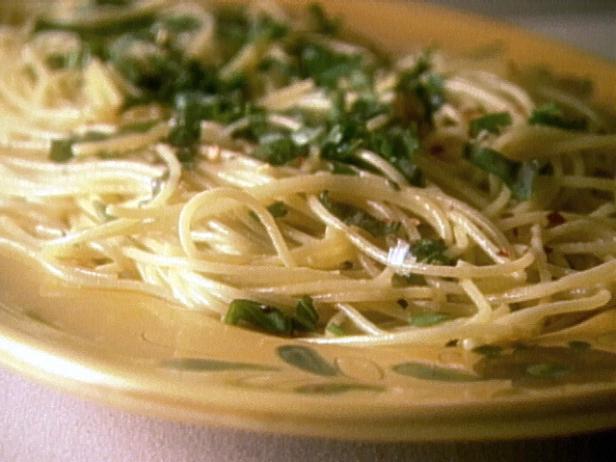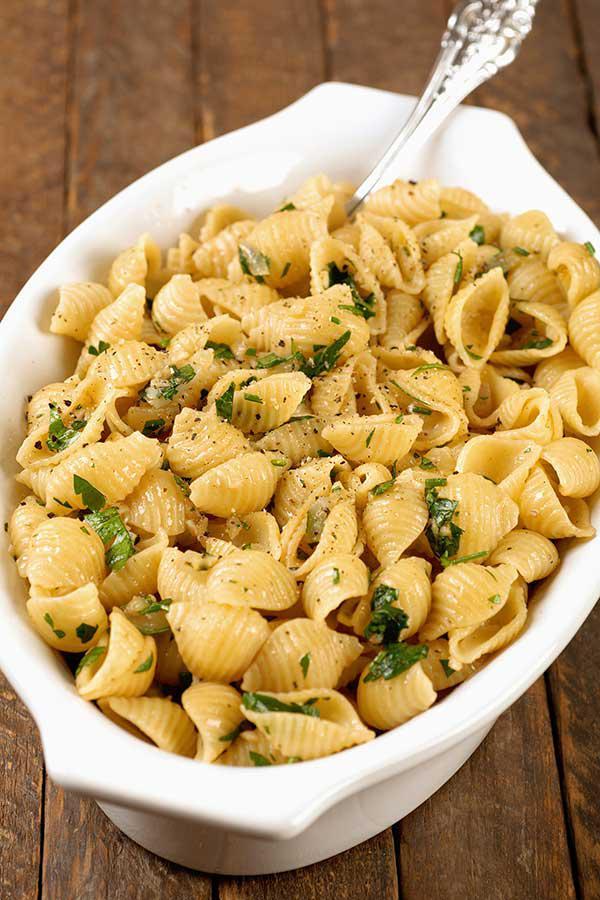The first image is the image on the left, the second image is the image on the right. Evaluate the accuracy of this statement regarding the images: "A silver utinsil is sitting in the bowl in one of the images.". Is it true? Answer yes or no. Yes. The first image is the image on the left, the second image is the image on the right. Assess this claim about the two images: "One image shows a pasta dish topped with sliced lemon.". Correct or not? Answer yes or no. No. 